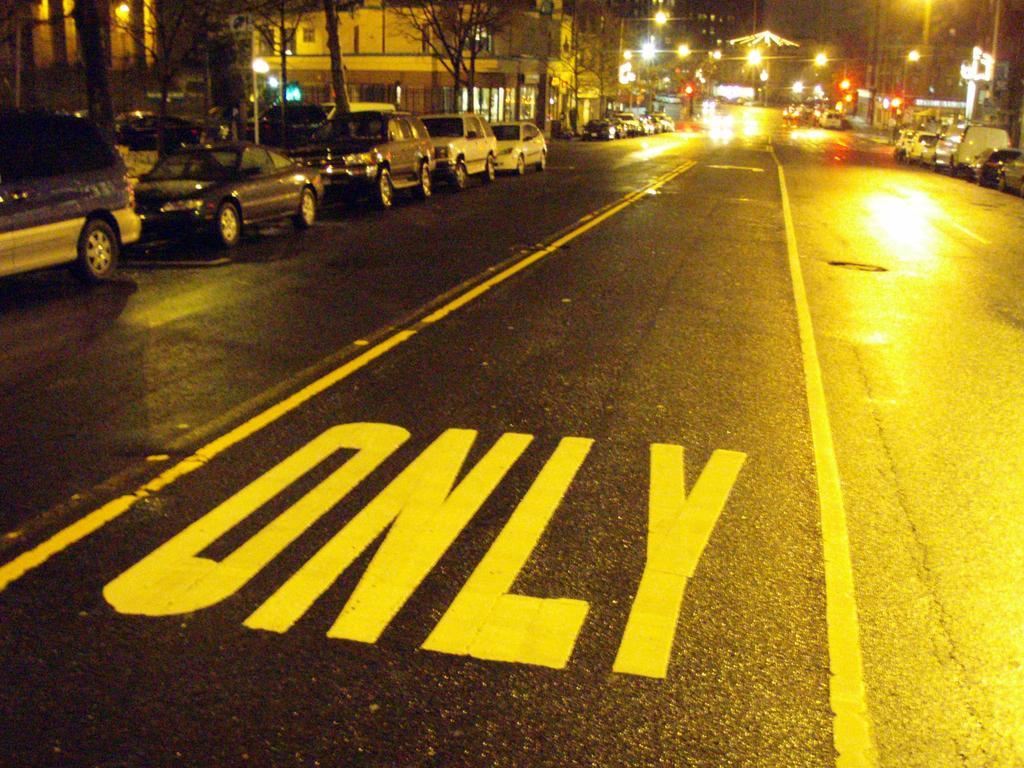Can you describe this image briefly? In this image on the road few vehicles are moving. In both sides of the road many cars are parked. in the background there are buildings,trees, lights. On the foreground on the road ¨ONLY¨ is written. 